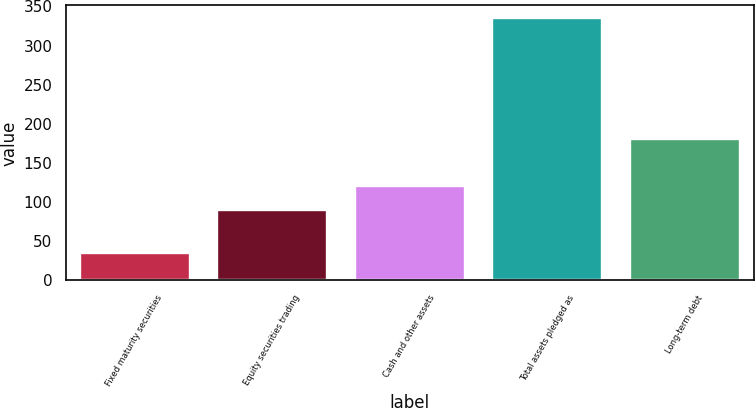Convert chart. <chart><loc_0><loc_0><loc_500><loc_500><bar_chart><fcel>Fixed maturity securities<fcel>Equity securities trading<fcel>Cash and other assets<fcel>Total assets pledged as<fcel>Long-term debt<nl><fcel>34.7<fcel>90.1<fcel>120.11<fcel>334.8<fcel>180.13<nl></chart> 